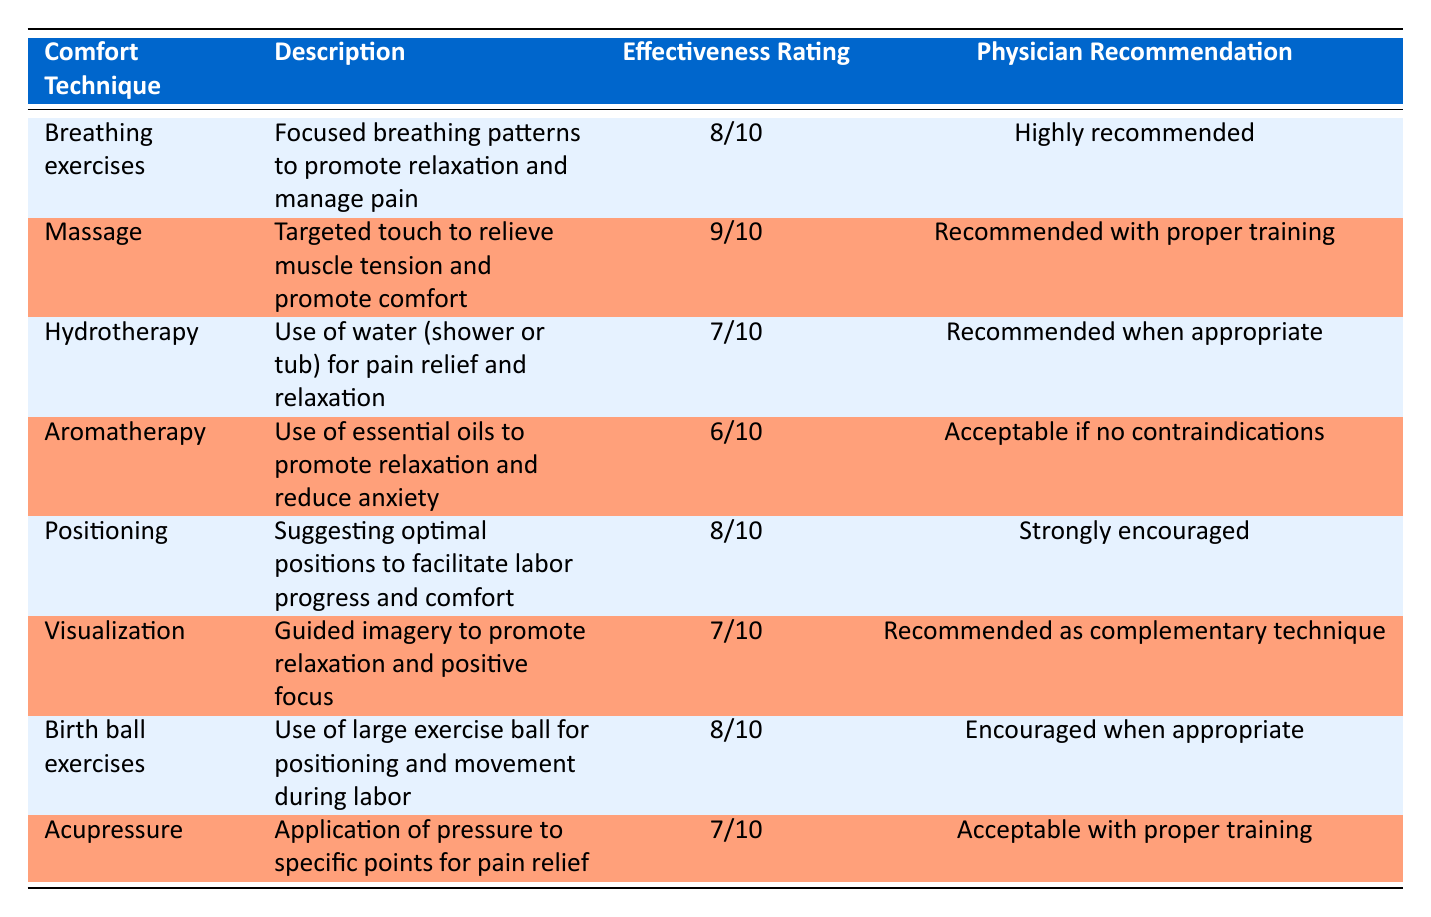What is the effectiveness rating of massage? The table lists the effectiveness rating for massage as "9/10". This value is explicitly stated in the "Effectiveness Rating" column corresponding to the "Massage" row.
Answer: 9/10 Which comfort technique has the strongest physician recommendation? By reviewing the "Physician Recommendation" column, we see "Strongly encouraged" listed under "Positioning". This is the strongest recommendation in comparison to other techniques.
Answer: Positioning What comfort techniques are rated 8/10 for effectiveness? The techniques rated 8/10 are "Breathing exercises", "Positioning", and "Birth ball exercises". They can be found by looking at the effectiveness ratings and identifying all rows with that specific rating.
Answer: Breathing exercises, Positioning, Birth ball exercises Is aromatherapy recommended by physicians? The table states that aromatherapy is "Acceptable if no contraindications". This implies that it is not a strong recommendation, but it can be used cautiously.
Answer: Yes What is the average effectiveness rating for the techniques listed? The effectiveness ratings are: 8, 9, 7, 6, 8, 7, 8, 7. Adding these values gives a total of 62 (8 + 9 + 7 + 6 + 8 + 7 + 8 + 7 = 62). There are 8 techniques, so we divide 62 by 8 to get the average, which is 7.75.
Answer: 7.75 Which comfort technique has the lowest effectiveness rating, and what is that rating? By reviewing all the effectiveness ratings, "Aromatherapy" has the lowest rating at "6/10". This is determined by comparing all the ratings in the table and identifying the minimum value.
Answer: 6/10 Are any comfort techniques acceptable only with proper training? Yes, both "Massage" and "Acupressure" are noted as "Recommended with proper training" and "Acceptable with proper training" respectively. This indicates that these techniques have conditions related to training.
Answer: Yes Which comfort technique offers visualization as part of its practice? The table explicitly mentions "Visualization", which refers to guided imagery used to promote relaxation. It can be found in the first column under the comfort technique section.
Answer: Visualization 